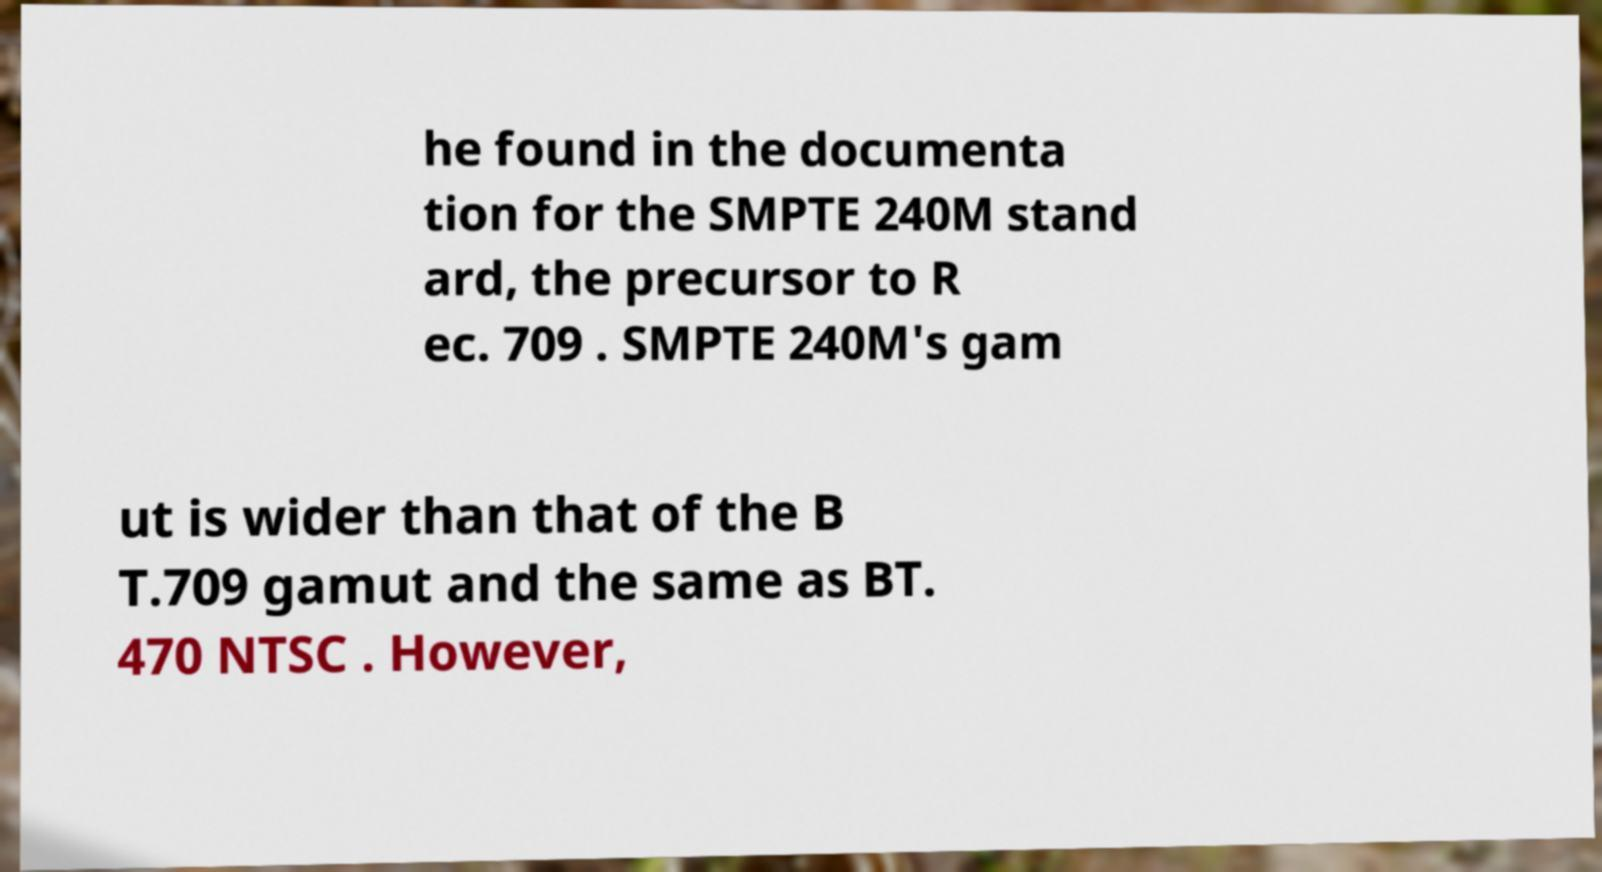Can you accurately transcribe the text from the provided image for me? he found in the documenta tion for the SMPTE 240M stand ard, the precursor to R ec. 709 . SMPTE 240M's gam ut is wider than that of the B T.709 gamut and the same as BT. 470 NTSC . However, 